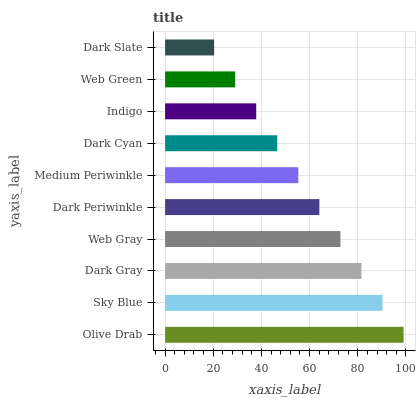Is Dark Slate the minimum?
Answer yes or no. Yes. Is Olive Drab the maximum?
Answer yes or no. Yes. Is Sky Blue the minimum?
Answer yes or no. No. Is Sky Blue the maximum?
Answer yes or no. No. Is Olive Drab greater than Sky Blue?
Answer yes or no. Yes. Is Sky Blue less than Olive Drab?
Answer yes or no. Yes. Is Sky Blue greater than Olive Drab?
Answer yes or no. No. Is Olive Drab less than Sky Blue?
Answer yes or no. No. Is Dark Periwinkle the high median?
Answer yes or no. Yes. Is Medium Periwinkle the low median?
Answer yes or no. Yes. Is Olive Drab the high median?
Answer yes or no. No. Is Dark Cyan the low median?
Answer yes or no. No. 